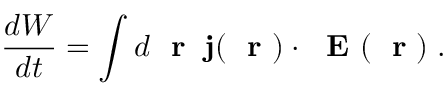<formula> <loc_0><loc_0><loc_500><loc_500>\frac { d W } { d t } = \int d r \, { j } ( r ) \cdot E ( r ) \, .</formula> 